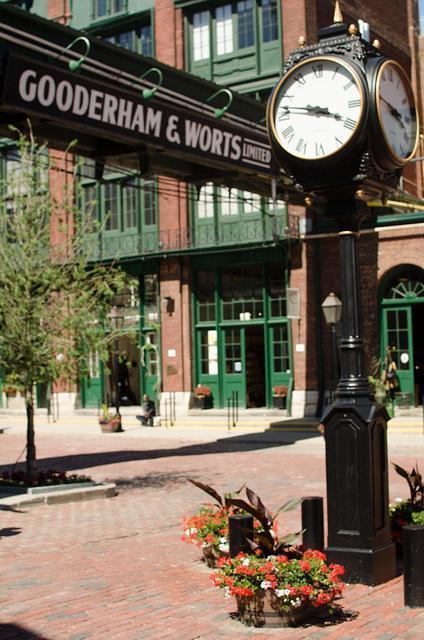In which setting is this clock?
Choose the correct response and explain in the format: 'Answer: answer
Rationale: rationale.'
Options: Tundra, suburban, rural, urban. Answer: urban.
Rationale: The clock is in a setting with tall buildings all around. 